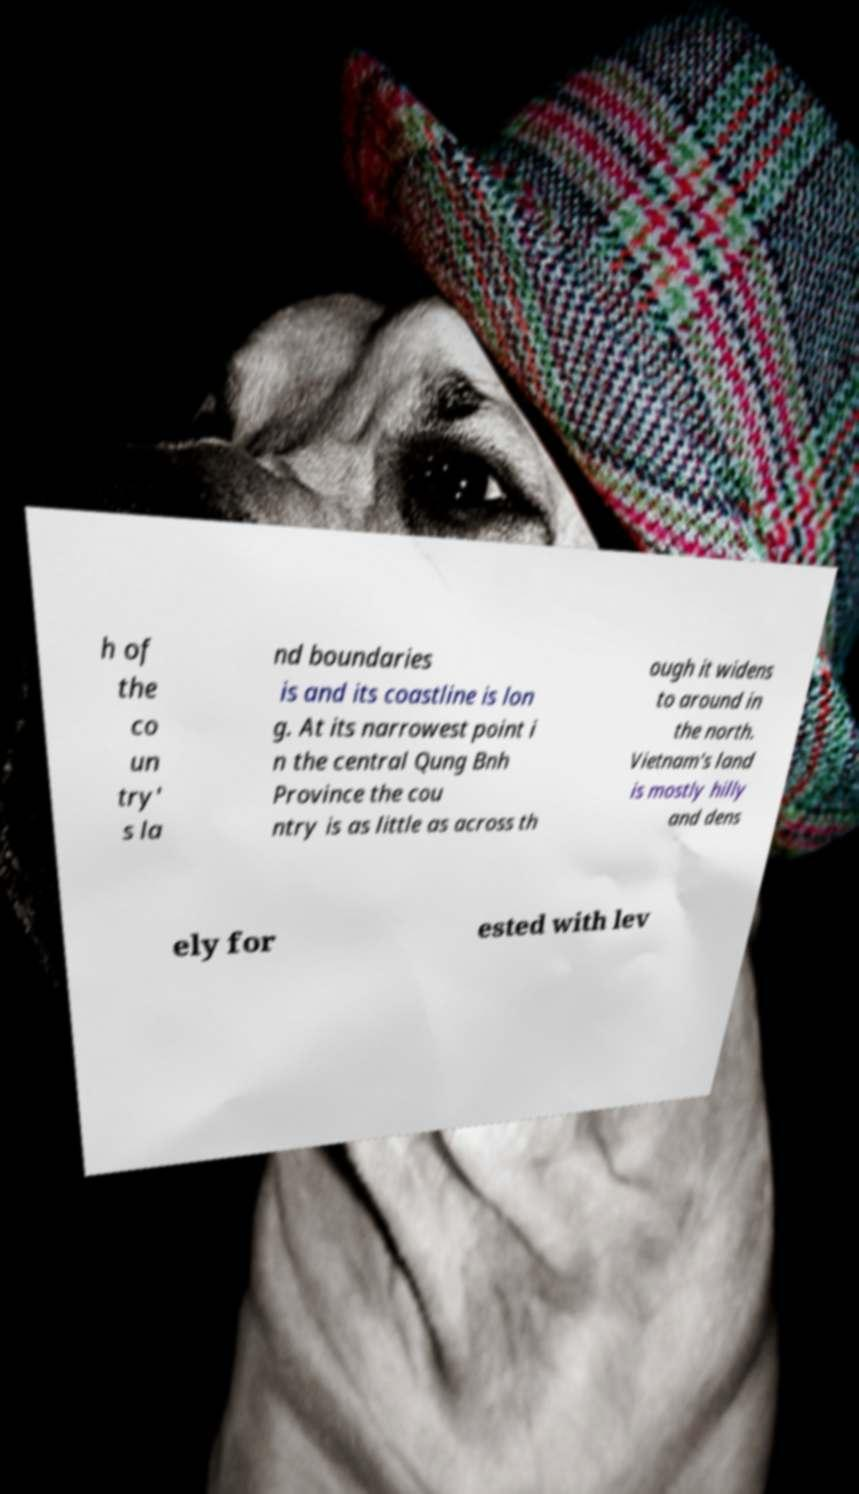Can you read and provide the text displayed in the image?This photo seems to have some interesting text. Can you extract and type it out for me? h of the co un try' s la nd boundaries is and its coastline is lon g. At its narrowest point i n the central Qung Bnh Province the cou ntry is as little as across th ough it widens to around in the north. Vietnam's land is mostly hilly and dens ely for ested with lev 